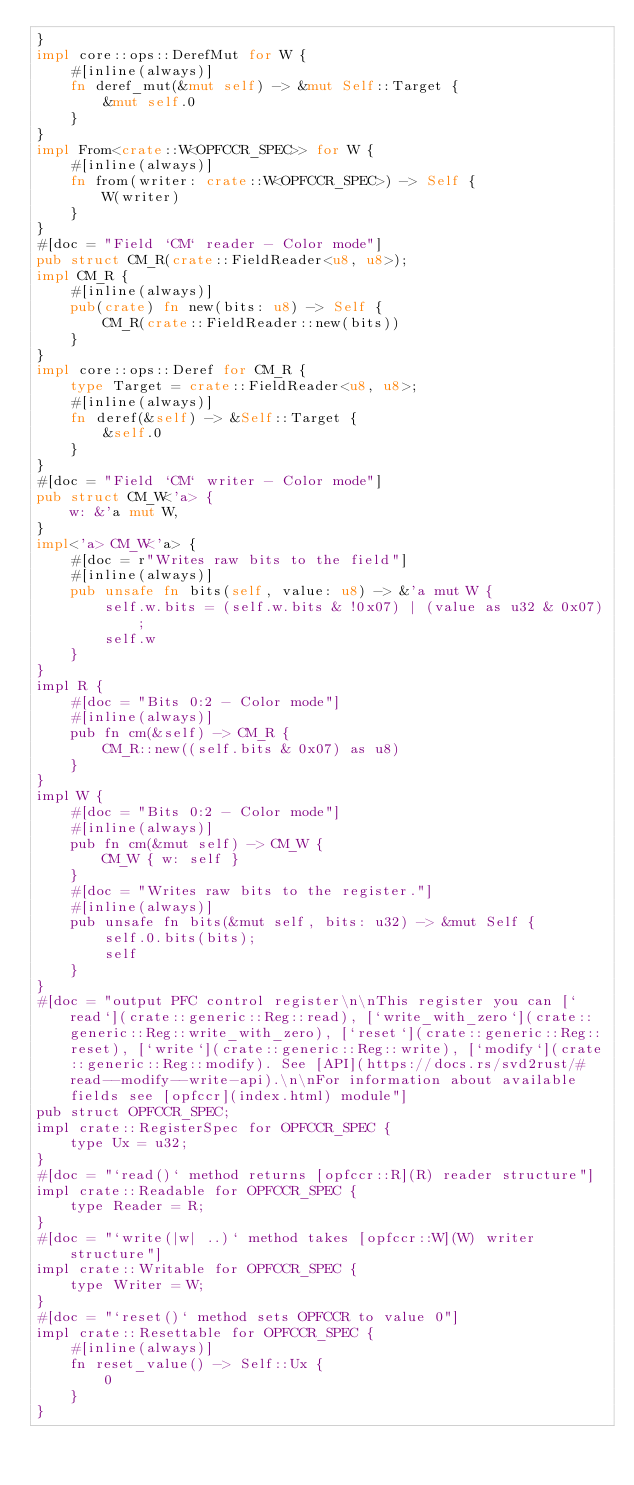<code> <loc_0><loc_0><loc_500><loc_500><_Rust_>}
impl core::ops::DerefMut for W {
    #[inline(always)]
    fn deref_mut(&mut self) -> &mut Self::Target {
        &mut self.0
    }
}
impl From<crate::W<OPFCCR_SPEC>> for W {
    #[inline(always)]
    fn from(writer: crate::W<OPFCCR_SPEC>) -> Self {
        W(writer)
    }
}
#[doc = "Field `CM` reader - Color mode"]
pub struct CM_R(crate::FieldReader<u8, u8>);
impl CM_R {
    #[inline(always)]
    pub(crate) fn new(bits: u8) -> Self {
        CM_R(crate::FieldReader::new(bits))
    }
}
impl core::ops::Deref for CM_R {
    type Target = crate::FieldReader<u8, u8>;
    #[inline(always)]
    fn deref(&self) -> &Self::Target {
        &self.0
    }
}
#[doc = "Field `CM` writer - Color mode"]
pub struct CM_W<'a> {
    w: &'a mut W,
}
impl<'a> CM_W<'a> {
    #[doc = r"Writes raw bits to the field"]
    #[inline(always)]
    pub unsafe fn bits(self, value: u8) -> &'a mut W {
        self.w.bits = (self.w.bits & !0x07) | (value as u32 & 0x07);
        self.w
    }
}
impl R {
    #[doc = "Bits 0:2 - Color mode"]
    #[inline(always)]
    pub fn cm(&self) -> CM_R {
        CM_R::new((self.bits & 0x07) as u8)
    }
}
impl W {
    #[doc = "Bits 0:2 - Color mode"]
    #[inline(always)]
    pub fn cm(&mut self) -> CM_W {
        CM_W { w: self }
    }
    #[doc = "Writes raw bits to the register."]
    #[inline(always)]
    pub unsafe fn bits(&mut self, bits: u32) -> &mut Self {
        self.0.bits(bits);
        self
    }
}
#[doc = "output PFC control register\n\nThis register you can [`read`](crate::generic::Reg::read), [`write_with_zero`](crate::generic::Reg::write_with_zero), [`reset`](crate::generic::Reg::reset), [`write`](crate::generic::Reg::write), [`modify`](crate::generic::Reg::modify). See [API](https://docs.rs/svd2rust/#read--modify--write-api).\n\nFor information about available fields see [opfccr](index.html) module"]
pub struct OPFCCR_SPEC;
impl crate::RegisterSpec for OPFCCR_SPEC {
    type Ux = u32;
}
#[doc = "`read()` method returns [opfccr::R](R) reader structure"]
impl crate::Readable for OPFCCR_SPEC {
    type Reader = R;
}
#[doc = "`write(|w| ..)` method takes [opfccr::W](W) writer structure"]
impl crate::Writable for OPFCCR_SPEC {
    type Writer = W;
}
#[doc = "`reset()` method sets OPFCCR to value 0"]
impl crate::Resettable for OPFCCR_SPEC {
    #[inline(always)]
    fn reset_value() -> Self::Ux {
        0
    }
}
</code> 